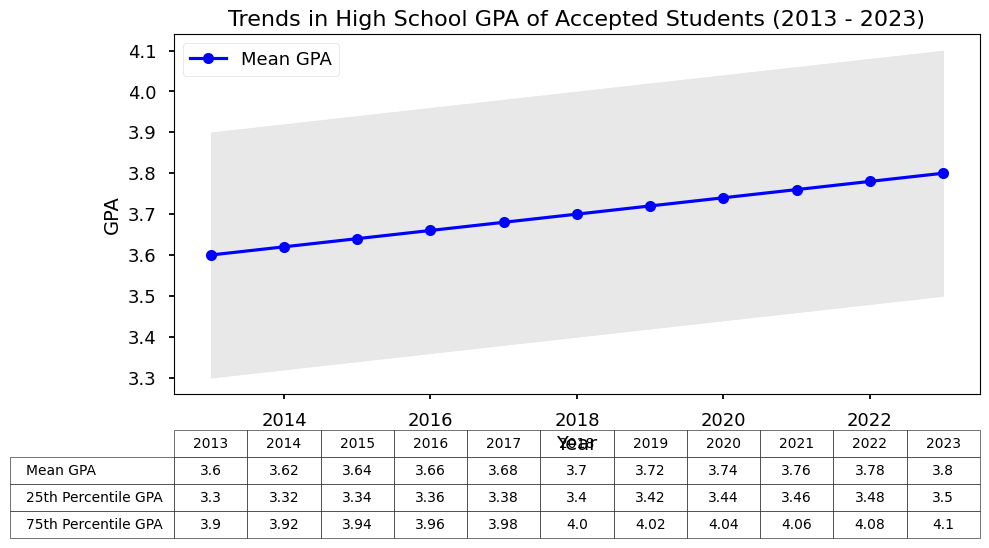What's the trend of the mean GPA from 2013 to 2023? The mean GPA shows a consistent increase from 3.60 in 2013 to 3.80 in 2023. This indicates a gradual upward trend in the academic performance of accepted students.
Answer: increasing In which year did the 75th percentile GPA reach 4.00? The 75th percentile GPA reached 4.00 in the year 2018. This can be seen from the table where the 75th percentile GPA for 2018 is 4.00.
Answer: 2018 By how much did the 25th percentile GPA increase from 2013 to 2023? The 25th percentile GPA in 2013 was 3.30, and in 2023 it was 3.50. The increase can be calculated as 3.50 - 3.30 = 0.20.
Answer: 0.20 Compare the mean GPA in 2013 and 2023. Which one is higher and by how much? The mean GPA in 2013 was 3.60 and in 2023 it was 3.80. The mean GPA in 2023 is higher by 3.80 - 3.60 = 0.20.
Answer: 2023, 0.20 What is the range of the GPA for the year 2017 based on the 25th and 75th percentiles? The range is found by subtracting the 25th percentile GPA from the 75th percentile GPA for 2017. This is 3.98 - 3.38 = 0.60.
Answer: 0.60 Which year had the highest 25th percentile GPA? The highest 25th percentile GPA occurred in 2023 with a value of 3.50.
Answer: 2023 What color is used to represent the mean GPA line in the figure? The mean GPA line is represented with a blue color in the figure. This is visually shown by the blue line that denotes the mean GPA.
Answer: blue Calculate the average mean GPA over the entire period from the data provided. To find the average mean GPA, sum the mean GPAs for each year and divide by the number of years: (3.60 + 3.62 + 3.64 + 3.66 + 3.68 + 3.70 + 3.72 + 3.74 + 3.76 + 3.78 + 3.80) / 11 = 3.694.
Answer: 3.694 Is there any year where the 25th percentile remained constant compared to the previous year? Each year shows a gradual increase in the 25th percentile GPA, so no year has a constant 25th percentile GPA compared to the previous year.
Answer: no 